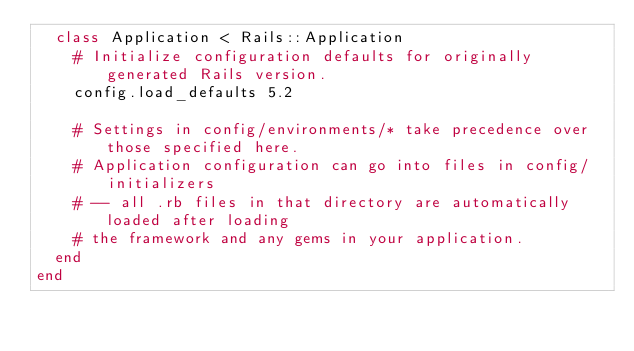Convert code to text. <code><loc_0><loc_0><loc_500><loc_500><_Ruby_>  class Application < Rails::Application
    # Initialize configuration defaults for originally generated Rails version.
    config.load_defaults 5.2

    # Settings in config/environments/* take precedence over those specified here.
    # Application configuration can go into files in config/initializers
    # -- all .rb files in that directory are automatically loaded after loading
    # the framework and any gems in your application.
  end
end
</code> 